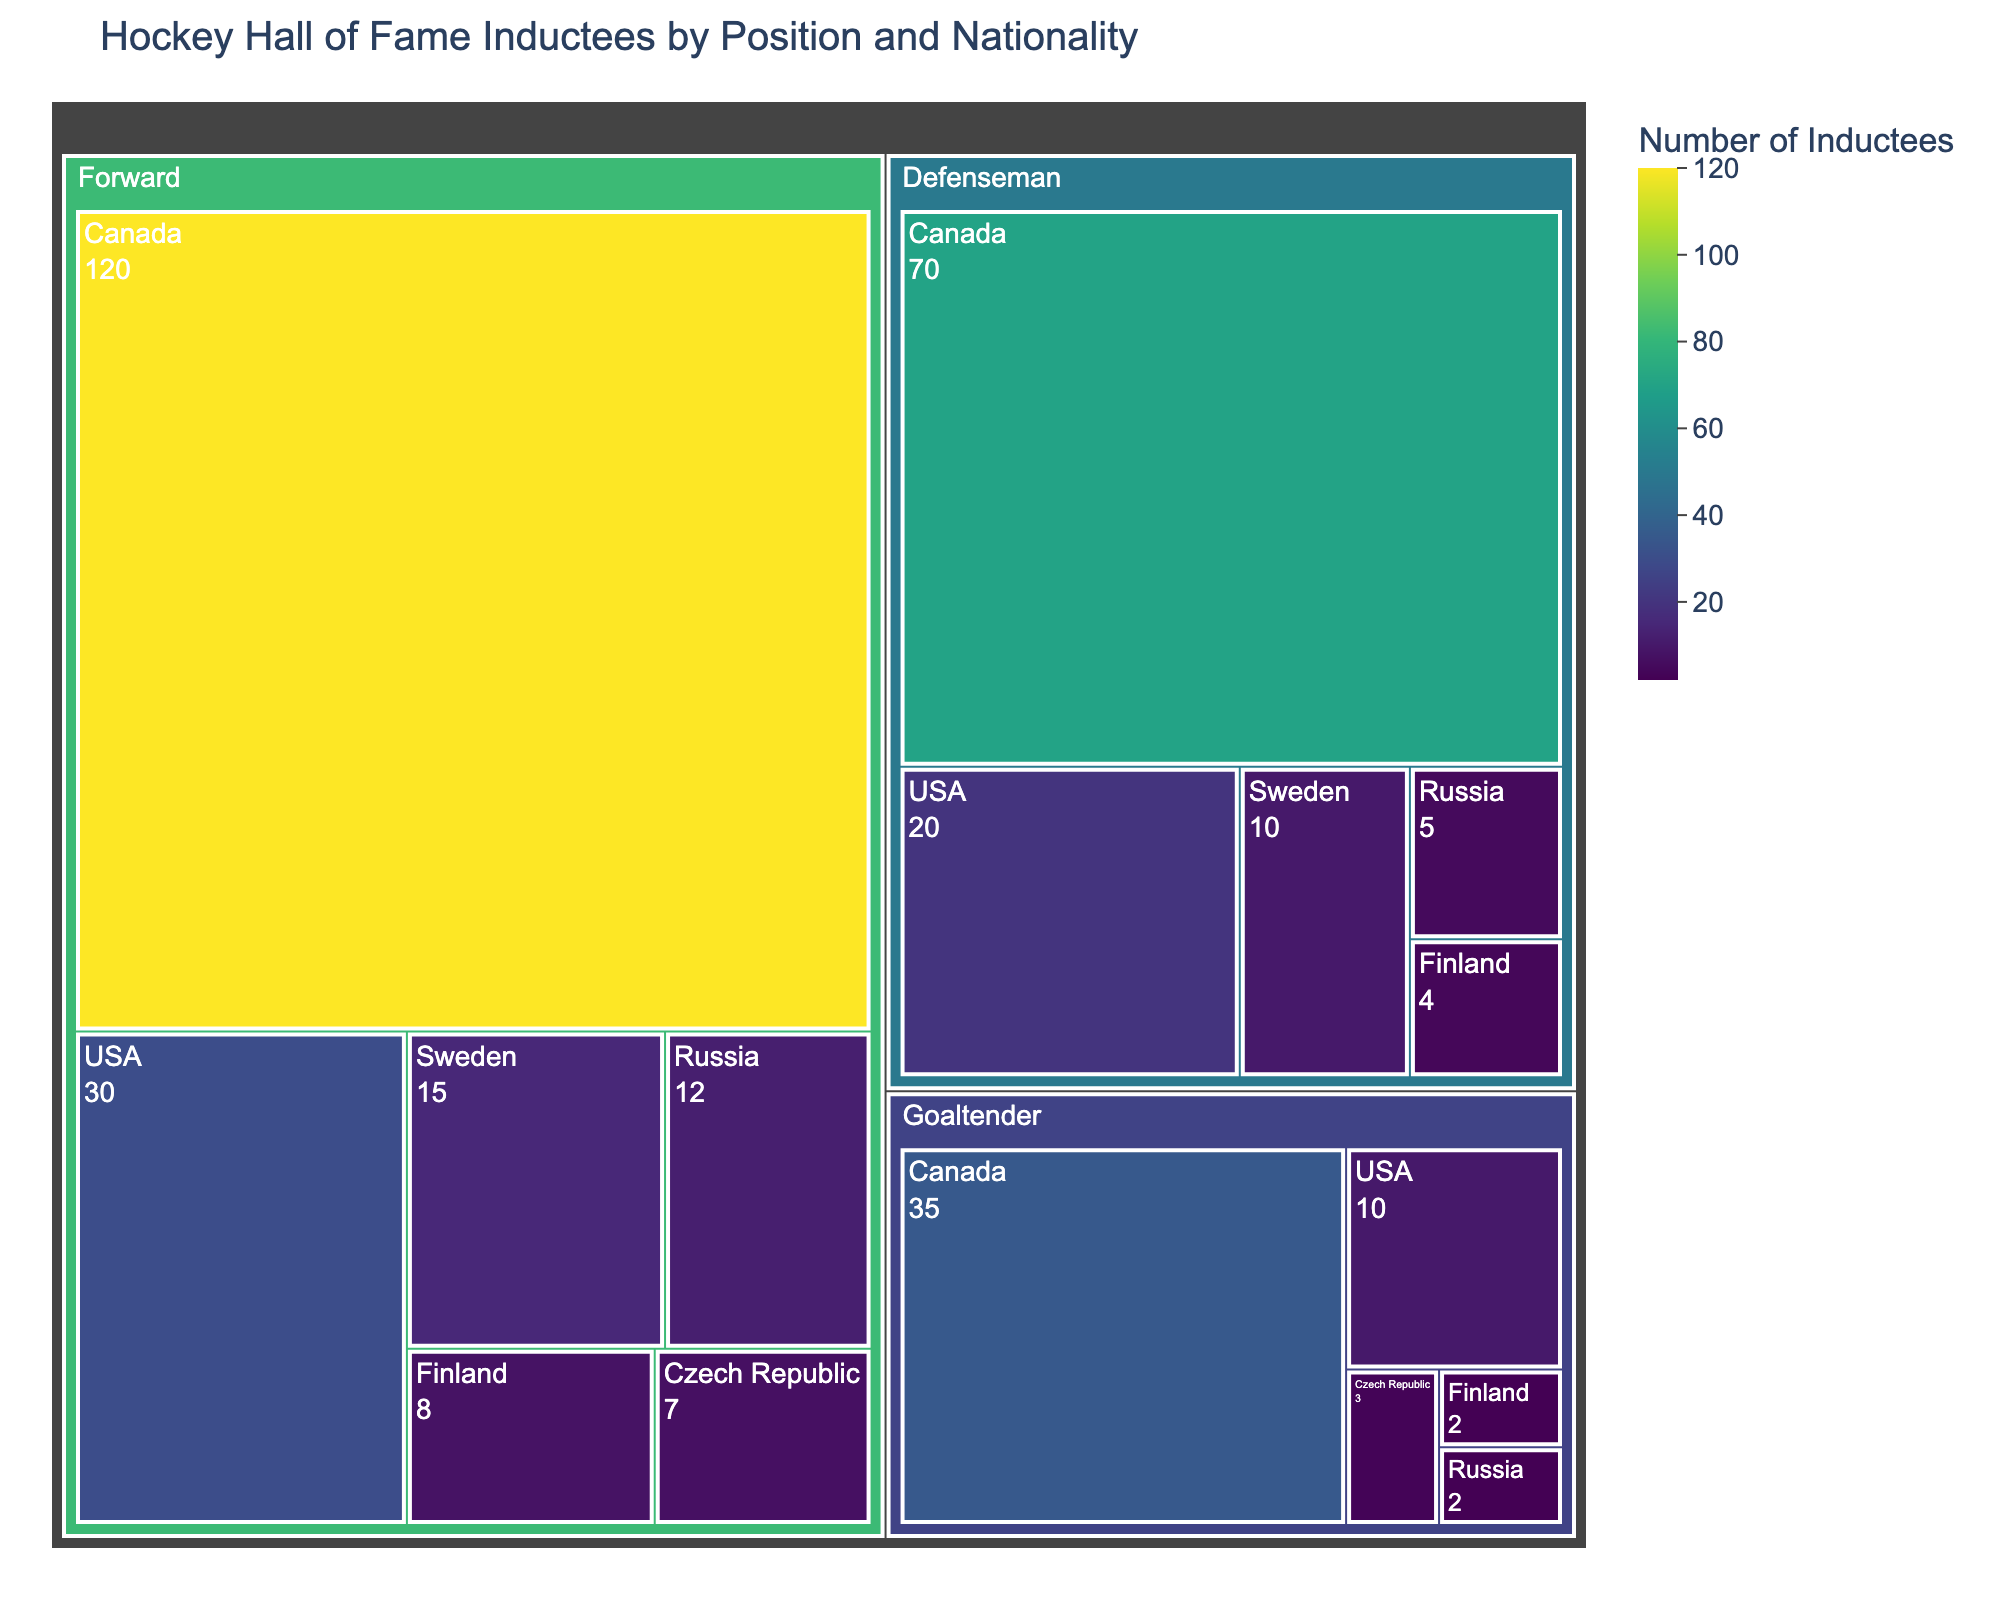What is the title of the treemap? The title is displayed at the top of the treemap, providing an overview of the content the plot represents.
Answer: Hockey Hall of Fame Inductees by Position and Nationality Which nationality has the most inductees for the forward position? By observing the size of the segmented areas representing each nationality under the "Forward" category, the largest area corresponds to Canada.
Answer: Canada How many Canadian defensemen are in the Hockey Hall of Fame? Locate the "Defenseman" category, and within that category, find the segment for Canada. The figure within that segment will tell the number of inductees.
Answer: 70 Which position has the fewest inductees from Finland? Check the different segmented areas for Finland and identify which of these is the smallest. You will see that "Goaltender" has the smallest number of inductees for Finland.
Answer: Goaltender Compare the number of forward inductees from Sweden and Finland. Which country has more and by how many? Locate the segments for Sweden and Finland under the "Forward" category. Sweden has 15 and Finland has 8 forward inductees. Subtract the smaller number from the larger to find the difference.
Answer: Sweden has 7 more forwards What is the total number of inductees from Canada? Add the numbers of inductees from Canada across all positions: Forward (120), Defenseman (70), Goaltender (35). This results in 120 + 70 + 35 = 225.
Answer: 225 What is the color representing the number of inductees in the legend, and which has the highest number? Colors in the legend will likely range from the lowest to highest. You need to find the position with the maximum number of inductees, which in this case is "Forward" under "Canada" with 120, represented in the darkest shade.
Answer: Darkest shade How many more inductees are there for USA defensemen compared to Russian defensemen? Locate the segments under the "Defenseman" category for USA and Russia. USA has 20 and Russia has 5. Subtract the smaller number from the larger (20 - 5) to find the difference.
Answer: 15 Which position generally has the largest number of inductees? Comparing the sizes of the largest segments under each position category will indicate which position has the most inductees overall. "Forward" has the largest number of inductees.
Answer: Forward 